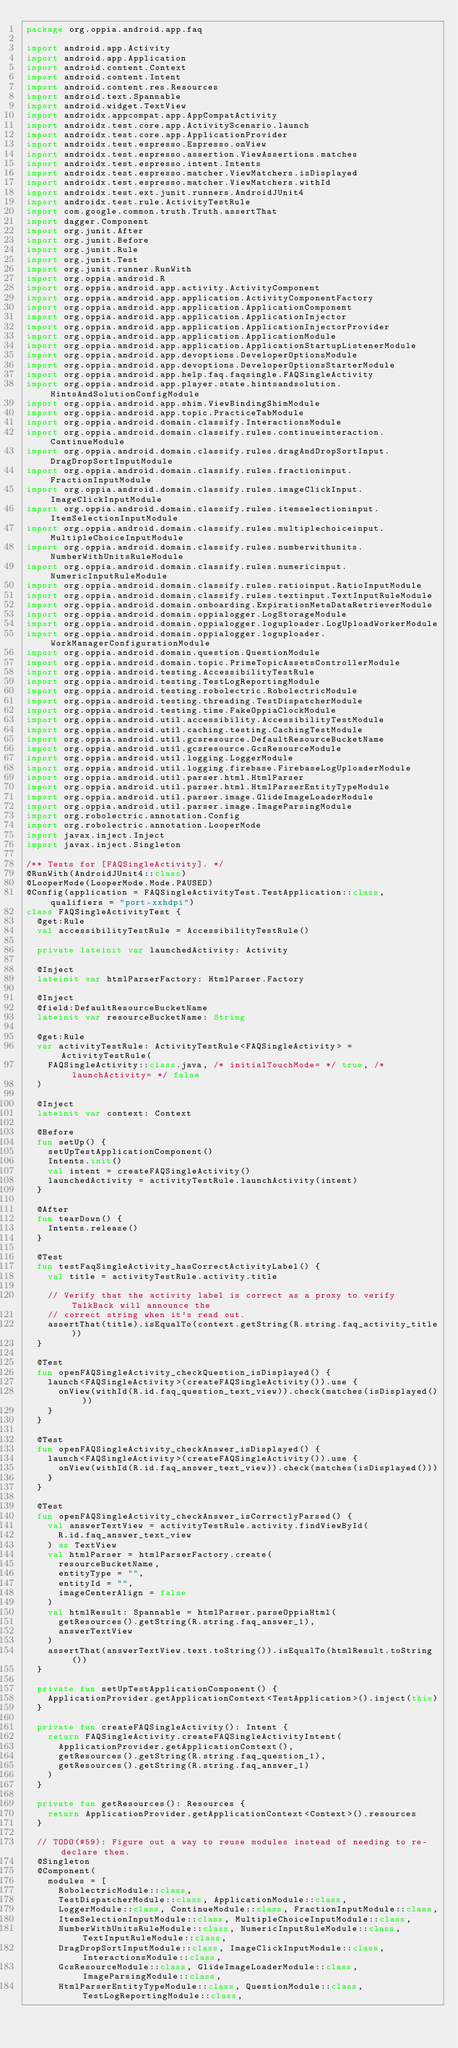<code> <loc_0><loc_0><loc_500><loc_500><_Kotlin_>package org.oppia.android.app.faq

import android.app.Activity
import android.app.Application
import android.content.Context
import android.content.Intent
import android.content.res.Resources
import android.text.Spannable
import android.widget.TextView
import androidx.appcompat.app.AppCompatActivity
import androidx.test.core.app.ActivityScenario.launch
import androidx.test.core.app.ApplicationProvider
import androidx.test.espresso.Espresso.onView
import androidx.test.espresso.assertion.ViewAssertions.matches
import androidx.test.espresso.intent.Intents
import androidx.test.espresso.matcher.ViewMatchers.isDisplayed
import androidx.test.espresso.matcher.ViewMatchers.withId
import androidx.test.ext.junit.runners.AndroidJUnit4
import androidx.test.rule.ActivityTestRule
import com.google.common.truth.Truth.assertThat
import dagger.Component
import org.junit.After
import org.junit.Before
import org.junit.Rule
import org.junit.Test
import org.junit.runner.RunWith
import org.oppia.android.R
import org.oppia.android.app.activity.ActivityComponent
import org.oppia.android.app.application.ActivityComponentFactory
import org.oppia.android.app.application.ApplicationComponent
import org.oppia.android.app.application.ApplicationInjector
import org.oppia.android.app.application.ApplicationInjectorProvider
import org.oppia.android.app.application.ApplicationModule
import org.oppia.android.app.application.ApplicationStartupListenerModule
import org.oppia.android.app.devoptions.DeveloperOptionsModule
import org.oppia.android.app.devoptions.DeveloperOptionsStarterModule
import org.oppia.android.app.help.faq.faqsingle.FAQSingleActivity
import org.oppia.android.app.player.state.hintsandsolution.HintsAndSolutionConfigModule
import org.oppia.android.app.shim.ViewBindingShimModule
import org.oppia.android.app.topic.PracticeTabModule
import org.oppia.android.domain.classify.InteractionsModule
import org.oppia.android.domain.classify.rules.continueinteraction.ContinueModule
import org.oppia.android.domain.classify.rules.dragAndDropSortInput.DragDropSortInputModule
import org.oppia.android.domain.classify.rules.fractioninput.FractionInputModule
import org.oppia.android.domain.classify.rules.imageClickInput.ImageClickInputModule
import org.oppia.android.domain.classify.rules.itemselectioninput.ItemSelectionInputModule
import org.oppia.android.domain.classify.rules.multiplechoiceinput.MultipleChoiceInputModule
import org.oppia.android.domain.classify.rules.numberwithunits.NumberWithUnitsRuleModule
import org.oppia.android.domain.classify.rules.numericinput.NumericInputRuleModule
import org.oppia.android.domain.classify.rules.ratioinput.RatioInputModule
import org.oppia.android.domain.classify.rules.textinput.TextInputRuleModule
import org.oppia.android.domain.onboarding.ExpirationMetaDataRetrieverModule
import org.oppia.android.domain.oppialogger.LogStorageModule
import org.oppia.android.domain.oppialogger.loguploader.LogUploadWorkerModule
import org.oppia.android.domain.oppialogger.loguploader.WorkManagerConfigurationModule
import org.oppia.android.domain.question.QuestionModule
import org.oppia.android.domain.topic.PrimeTopicAssetsControllerModule
import org.oppia.android.testing.AccessibilityTestRule
import org.oppia.android.testing.TestLogReportingModule
import org.oppia.android.testing.robolectric.RobolectricModule
import org.oppia.android.testing.threading.TestDispatcherModule
import org.oppia.android.testing.time.FakeOppiaClockModule
import org.oppia.android.util.accessibility.AccessibilityTestModule
import org.oppia.android.util.caching.testing.CachingTestModule
import org.oppia.android.util.gcsresource.DefaultResourceBucketName
import org.oppia.android.util.gcsresource.GcsResourceModule
import org.oppia.android.util.logging.LoggerModule
import org.oppia.android.util.logging.firebase.FirebaseLogUploaderModule
import org.oppia.android.util.parser.html.HtmlParser
import org.oppia.android.util.parser.html.HtmlParserEntityTypeModule
import org.oppia.android.util.parser.image.GlideImageLoaderModule
import org.oppia.android.util.parser.image.ImageParsingModule
import org.robolectric.annotation.Config
import org.robolectric.annotation.LooperMode
import javax.inject.Inject
import javax.inject.Singleton

/** Tests for [FAQSingleActivity]. */
@RunWith(AndroidJUnit4::class)
@LooperMode(LooperMode.Mode.PAUSED)
@Config(application = FAQSingleActivityTest.TestApplication::class, qualifiers = "port-xxhdpi")
class FAQSingleActivityTest {
  @get:Rule
  val accessibilityTestRule = AccessibilityTestRule()

  private lateinit var launchedActivity: Activity

  @Inject
  lateinit var htmlParserFactory: HtmlParser.Factory

  @Inject
  @field:DefaultResourceBucketName
  lateinit var resourceBucketName: String

  @get:Rule
  var activityTestRule: ActivityTestRule<FAQSingleActivity> = ActivityTestRule(
    FAQSingleActivity::class.java, /* initialTouchMode= */ true, /* launchActivity= */ false
  )

  @Inject
  lateinit var context: Context

  @Before
  fun setUp() {
    setUpTestApplicationComponent()
    Intents.init()
    val intent = createFAQSingleActivity()
    launchedActivity = activityTestRule.launchActivity(intent)
  }

  @After
  fun tearDown() {
    Intents.release()
  }

  @Test
  fun testFaqSingleActivity_hasCorrectActivityLabel() {
    val title = activityTestRule.activity.title

    // Verify that the activity label is correct as a proxy to verify TalkBack will announce the
    // correct string when it's read out.
    assertThat(title).isEqualTo(context.getString(R.string.faq_activity_title))
  }

  @Test
  fun openFAQSingleActivity_checkQuestion_isDisplayed() {
    launch<FAQSingleActivity>(createFAQSingleActivity()).use {
      onView(withId(R.id.faq_question_text_view)).check(matches(isDisplayed()))
    }
  }

  @Test
  fun openFAQSingleActivity_checkAnswer_isDisplayed() {
    launch<FAQSingleActivity>(createFAQSingleActivity()).use {
      onView(withId(R.id.faq_answer_text_view)).check(matches(isDisplayed()))
    }
  }

  @Test
  fun openFAQSingleActivity_checkAnswer_isCorrectlyParsed() {
    val answerTextView = activityTestRule.activity.findViewById(
      R.id.faq_answer_text_view
    ) as TextView
    val htmlParser = htmlParserFactory.create(
      resourceBucketName,
      entityType = "",
      entityId = "",
      imageCenterAlign = false
    )
    val htmlResult: Spannable = htmlParser.parseOppiaHtml(
      getResources().getString(R.string.faq_answer_1),
      answerTextView
    )
    assertThat(answerTextView.text.toString()).isEqualTo(htmlResult.toString())
  }

  private fun setUpTestApplicationComponent() {
    ApplicationProvider.getApplicationContext<TestApplication>().inject(this)
  }

  private fun createFAQSingleActivity(): Intent {
    return FAQSingleActivity.createFAQSingleActivityIntent(
      ApplicationProvider.getApplicationContext(),
      getResources().getString(R.string.faq_question_1),
      getResources().getString(R.string.faq_answer_1)
    )
  }

  private fun getResources(): Resources {
    return ApplicationProvider.getApplicationContext<Context>().resources
  }

  // TODO(#59): Figure out a way to reuse modules instead of needing to re-declare them.
  @Singleton
  @Component(
    modules = [
      RobolectricModule::class,
      TestDispatcherModule::class, ApplicationModule::class,
      LoggerModule::class, ContinueModule::class, FractionInputModule::class,
      ItemSelectionInputModule::class, MultipleChoiceInputModule::class,
      NumberWithUnitsRuleModule::class, NumericInputRuleModule::class, TextInputRuleModule::class,
      DragDropSortInputModule::class, ImageClickInputModule::class, InteractionsModule::class,
      GcsResourceModule::class, GlideImageLoaderModule::class, ImageParsingModule::class,
      HtmlParserEntityTypeModule::class, QuestionModule::class, TestLogReportingModule::class,</code> 